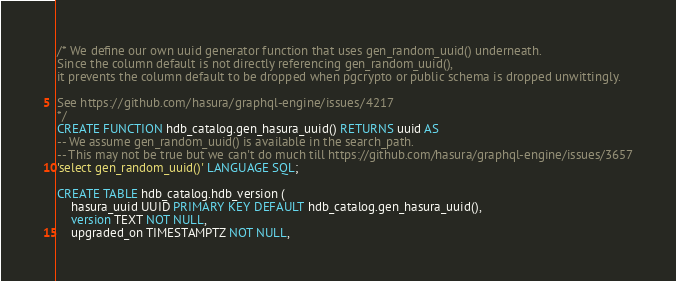Convert code to text. <code><loc_0><loc_0><loc_500><loc_500><_SQL_>/* We define our own uuid generator function that uses gen_random_uuid() underneath.
Since the column default is not directly referencing gen_random_uuid(),
it prevents the column default to be dropped when pgcrypto or public schema is dropped unwittingly.

See https://github.com/hasura/graphql-engine/issues/4217
*/
CREATE FUNCTION hdb_catalog.gen_hasura_uuid() RETURNS uuid AS
-- We assume gen_random_uuid() is available in the search_path.
-- This may not be true but we can't do much till https://github.com/hasura/graphql-engine/issues/3657
'select gen_random_uuid()' LANGUAGE SQL;

CREATE TABLE hdb_catalog.hdb_version (
    hasura_uuid UUID PRIMARY KEY DEFAULT hdb_catalog.gen_hasura_uuid(),
    version TEXT NOT NULL,
    upgraded_on TIMESTAMPTZ NOT NULL,</code> 